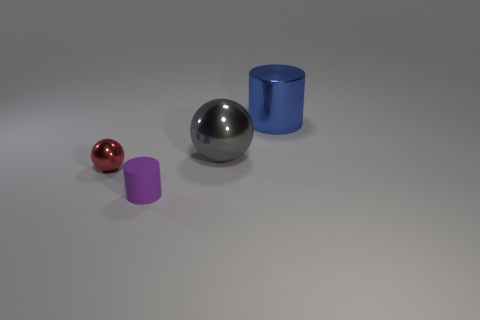Do the blue cylinder and the gray sphere have the same material?
Your response must be concise. Yes. Are there any big gray objects on the left side of the tiny red metallic thing?
Provide a short and direct response. No. There is a cylinder to the left of the ball that is behind the red thing; what is it made of?
Your answer should be compact. Rubber. There is a red object that is the same shape as the gray shiny thing; what size is it?
Your answer should be compact. Small. There is a metallic object that is in front of the blue thing and behind the tiny red metal ball; what is its color?
Your answer should be very brief. Gray. There is a metallic ball right of the red object; is it the same size as the large blue object?
Give a very brief answer. Yes. Are the gray ball and the small cylinder that is in front of the large gray sphere made of the same material?
Your response must be concise. No. What number of red things are either metal things or large metal cylinders?
Provide a short and direct response. 1. Are there any small green metallic objects?
Keep it short and to the point. No. Is there a big object that is behind the thing to the left of the small cylinder in front of the gray thing?
Offer a very short reply. Yes. 